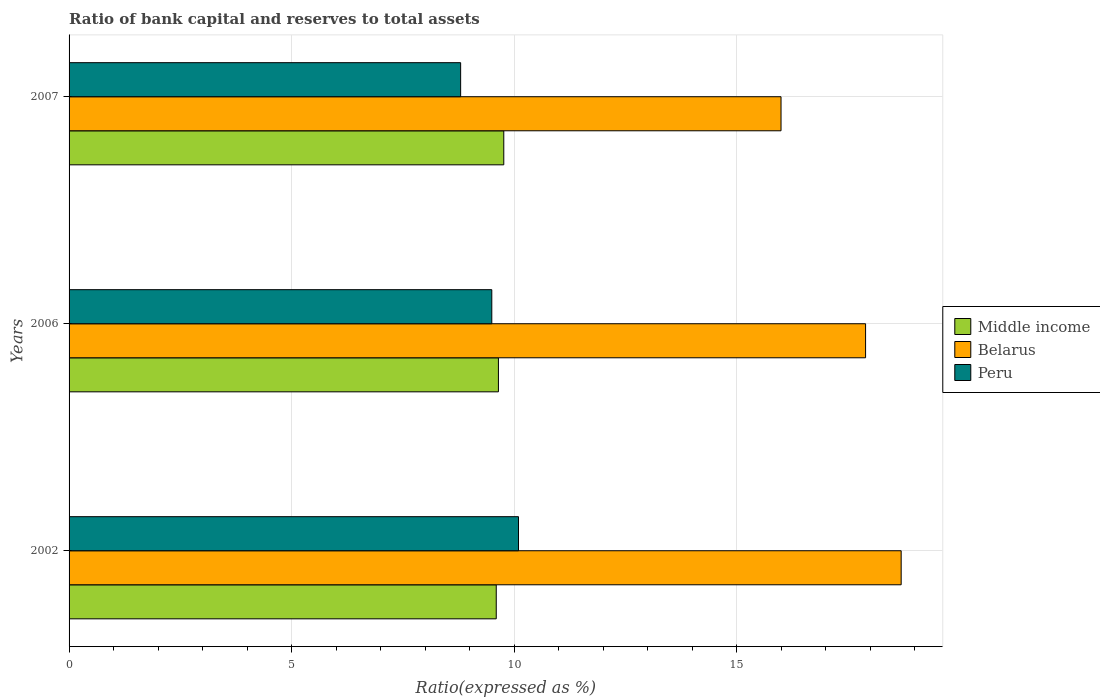How many groups of bars are there?
Give a very brief answer. 3. How many bars are there on the 1st tick from the bottom?
Provide a short and direct response. 3. What is the label of the 1st group of bars from the top?
Offer a terse response. 2007. What is the ratio of bank capital and reserves to total assets in Belarus in 2007?
Give a very brief answer. 16. What is the total ratio of bank capital and reserves to total assets in Middle income in the graph?
Your response must be concise. 29.02. What is the difference between the ratio of bank capital and reserves to total assets in Middle income in 2006 and that in 2007?
Provide a succinct answer. -0.12. What is the difference between the ratio of bank capital and reserves to total assets in Middle income in 2006 and the ratio of bank capital and reserves to total assets in Peru in 2007?
Provide a succinct answer. 0.85. What is the average ratio of bank capital and reserves to total assets in Middle income per year?
Make the answer very short. 9.67. What is the ratio of the ratio of bank capital and reserves to total assets in Peru in 2002 to that in 2007?
Ensure brevity in your answer.  1.15. Is the ratio of bank capital and reserves to total assets in Middle income in 2006 less than that in 2007?
Your response must be concise. Yes. What is the difference between the highest and the second highest ratio of bank capital and reserves to total assets in Middle income?
Provide a succinct answer. 0.12. What is the difference between the highest and the lowest ratio of bank capital and reserves to total assets in Belarus?
Keep it short and to the point. 2.7. Is the sum of the ratio of bank capital and reserves to total assets in Middle income in 2002 and 2006 greater than the maximum ratio of bank capital and reserves to total assets in Belarus across all years?
Make the answer very short. Yes. What does the 1st bar from the top in 2007 represents?
Your answer should be compact. Peru. What does the 2nd bar from the bottom in 2006 represents?
Provide a short and direct response. Belarus. Is it the case that in every year, the sum of the ratio of bank capital and reserves to total assets in Belarus and ratio of bank capital and reserves to total assets in Peru is greater than the ratio of bank capital and reserves to total assets in Middle income?
Provide a short and direct response. Yes. How many bars are there?
Your answer should be very brief. 9. How many years are there in the graph?
Keep it short and to the point. 3. Are the values on the major ticks of X-axis written in scientific E-notation?
Give a very brief answer. No. Where does the legend appear in the graph?
Your response must be concise. Center right. What is the title of the graph?
Your answer should be very brief. Ratio of bank capital and reserves to total assets. Does "Norway" appear as one of the legend labels in the graph?
Your answer should be very brief. No. What is the label or title of the X-axis?
Your answer should be very brief. Ratio(expressed as %). What is the Ratio(expressed as %) of Middle income in 2006?
Make the answer very short. 9.65. What is the Ratio(expressed as %) in Middle income in 2007?
Offer a terse response. 9.77. Across all years, what is the maximum Ratio(expressed as %) in Middle income?
Offer a very short reply. 9.77. Across all years, what is the maximum Ratio(expressed as %) of Belarus?
Provide a short and direct response. 18.7. Across all years, what is the minimum Ratio(expressed as %) of Middle income?
Your answer should be compact. 9.6. Across all years, what is the minimum Ratio(expressed as %) in Belarus?
Your answer should be compact. 16. What is the total Ratio(expressed as %) in Middle income in the graph?
Give a very brief answer. 29.02. What is the total Ratio(expressed as %) of Belarus in the graph?
Your answer should be very brief. 52.6. What is the total Ratio(expressed as %) of Peru in the graph?
Give a very brief answer. 28.4. What is the difference between the Ratio(expressed as %) of Middle income in 2002 and that in 2006?
Ensure brevity in your answer.  -0.05. What is the difference between the Ratio(expressed as %) in Middle income in 2002 and that in 2007?
Make the answer very short. -0.17. What is the difference between the Ratio(expressed as %) in Middle income in 2006 and that in 2007?
Your answer should be very brief. -0.12. What is the difference between the Ratio(expressed as %) of Peru in 2006 and that in 2007?
Ensure brevity in your answer.  0.7. What is the difference between the Ratio(expressed as %) of Middle income in 2002 and the Ratio(expressed as %) of Belarus in 2006?
Give a very brief answer. -8.3. What is the difference between the Ratio(expressed as %) of Middle income in 2002 and the Ratio(expressed as %) of Peru in 2006?
Your response must be concise. 0.1. What is the difference between the Ratio(expressed as %) in Middle income in 2002 and the Ratio(expressed as %) in Belarus in 2007?
Your response must be concise. -6.4. What is the difference between the Ratio(expressed as %) in Middle income in 2002 and the Ratio(expressed as %) in Peru in 2007?
Your answer should be compact. 0.8. What is the difference between the Ratio(expressed as %) in Belarus in 2002 and the Ratio(expressed as %) in Peru in 2007?
Keep it short and to the point. 9.9. What is the difference between the Ratio(expressed as %) of Middle income in 2006 and the Ratio(expressed as %) of Belarus in 2007?
Your answer should be very brief. -6.35. What is the difference between the Ratio(expressed as %) of Middle income in 2006 and the Ratio(expressed as %) of Peru in 2007?
Give a very brief answer. 0.85. What is the average Ratio(expressed as %) in Middle income per year?
Your answer should be compact. 9.67. What is the average Ratio(expressed as %) in Belarus per year?
Your answer should be compact. 17.53. What is the average Ratio(expressed as %) in Peru per year?
Offer a terse response. 9.47. In the year 2002, what is the difference between the Ratio(expressed as %) of Middle income and Ratio(expressed as %) of Belarus?
Your response must be concise. -9.1. In the year 2002, what is the difference between the Ratio(expressed as %) of Belarus and Ratio(expressed as %) of Peru?
Provide a short and direct response. 8.6. In the year 2006, what is the difference between the Ratio(expressed as %) of Middle income and Ratio(expressed as %) of Belarus?
Keep it short and to the point. -8.25. In the year 2006, what is the difference between the Ratio(expressed as %) of Middle income and Ratio(expressed as %) of Peru?
Provide a short and direct response. 0.15. In the year 2006, what is the difference between the Ratio(expressed as %) in Belarus and Ratio(expressed as %) in Peru?
Provide a succinct answer. 8.4. In the year 2007, what is the difference between the Ratio(expressed as %) in Middle income and Ratio(expressed as %) in Belarus?
Offer a very short reply. -6.23. In the year 2007, what is the difference between the Ratio(expressed as %) in Middle income and Ratio(expressed as %) in Peru?
Your answer should be very brief. 0.97. In the year 2007, what is the difference between the Ratio(expressed as %) of Belarus and Ratio(expressed as %) of Peru?
Your answer should be very brief. 7.2. What is the ratio of the Ratio(expressed as %) in Belarus in 2002 to that in 2006?
Offer a terse response. 1.04. What is the ratio of the Ratio(expressed as %) in Peru in 2002 to that in 2006?
Provide a short and direct response. 1.06. What is the ratio of the Ratio(expressed as %) in Middle income in 2002 to that in 2007?
Offer a very short reply. 0.98. What is the ratio of the Ratio(expressed as %) of Belarus in 2002 to that in 2007?
Make the answer very short. 1.17. What is the ratio of the Ratio(expressed as %) in Peru in 2002 to that in 2007?
Ensure brevity in your answer.  1.15. What is the ratio of the Ratio(expressed as %) in Belarus in 2006 to that in 2007?
Offer a terse response. 1.12. What is the ratio of the Ratio(expressed as %) of Peru in 2006 to that in 2007?
Offer a very short reply. 1.08. What is the difference between the highest and the second highest Ratio(expressed as %) in Middle income?
Your answer should be compact. 0.12. What is the difference between the highest and the second highest Ratio(expressed as %) of Peru?
Ensure brevity in your answer.  0.6. What is the difference between the highest and the lowest Ratio(expressed as %) of Middle income?
Offer a terse response. 0.17. What is the difference between the highest and the lowest Ratio(expressed as %) in Peru?
Make the answer very short. 1.3. 